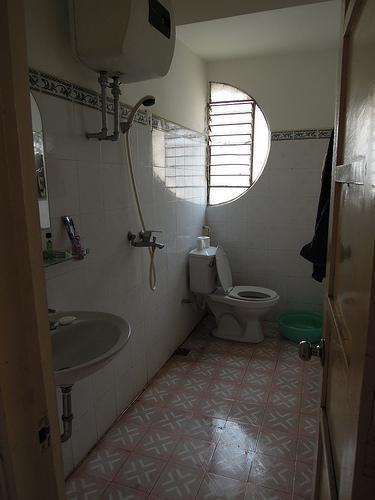How many sinks are seen?
Give a very brief answer. 1. 